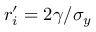<formula> <loc_0><loc_0><loc_500><loc_500>r _ { i } ^ { \prime } = 2 \gamma / \sigma _ { y }</formula> 